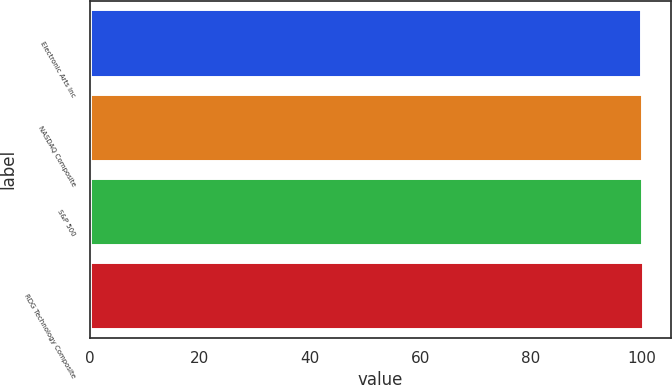Convert chart to OTSL. <chart><loc_0><loc_0><loc_500><loc_500><bar_chart><fcel>Electronic Arts Inc<fcel>NASDAQ Composite<fcel>S&P 500<fcel>RDG Technology Composite<nl><fcel>100<fcel>100.1<fcel>100.2<fcel>100.3<nl></chart> 